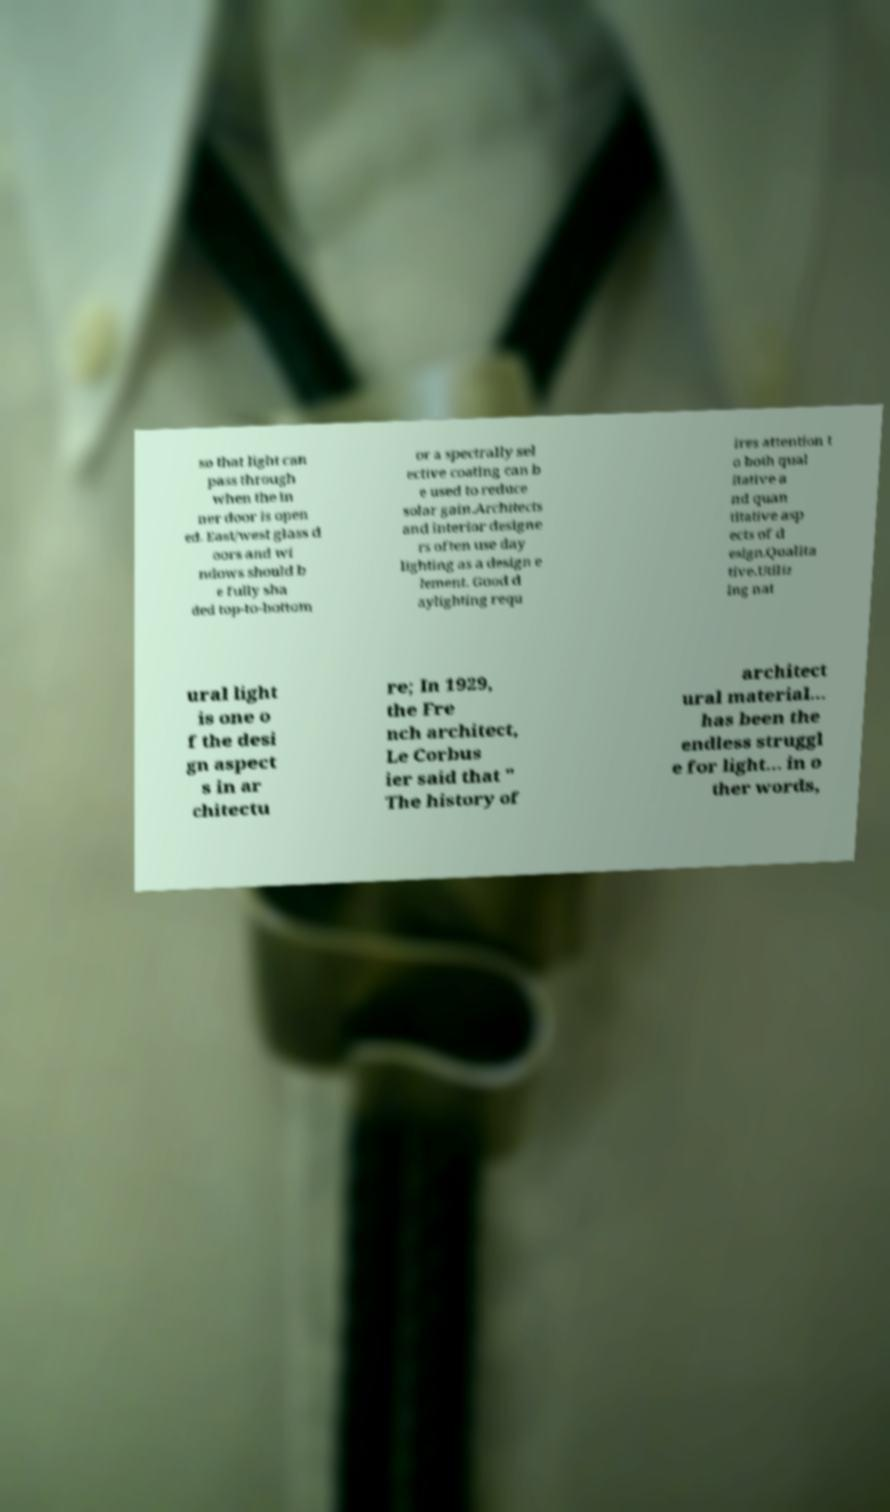Please identify and transcribe the text found in this image. so that light can pass through when the in ner door is open ed. East/west glass d oors and wi ndows should b e fully sha ded top-to-bottom or a spectrally sel ective coating can b e used to reduce solar gain.Architects and interior designe rs often use day lighting as a design e lement. Good d aylighting requ ires attention t o both qual itative a nd quan titative asp ects of d esign.Qualita tive.Utiliz ing nat ural light is one o f the desi gn aspect s in ar chitectu re; In 1929, the Fre nch architect, Le Corbus ier said that " The history of architect ural material... has been the endless struggl e for light... in o ther words, 